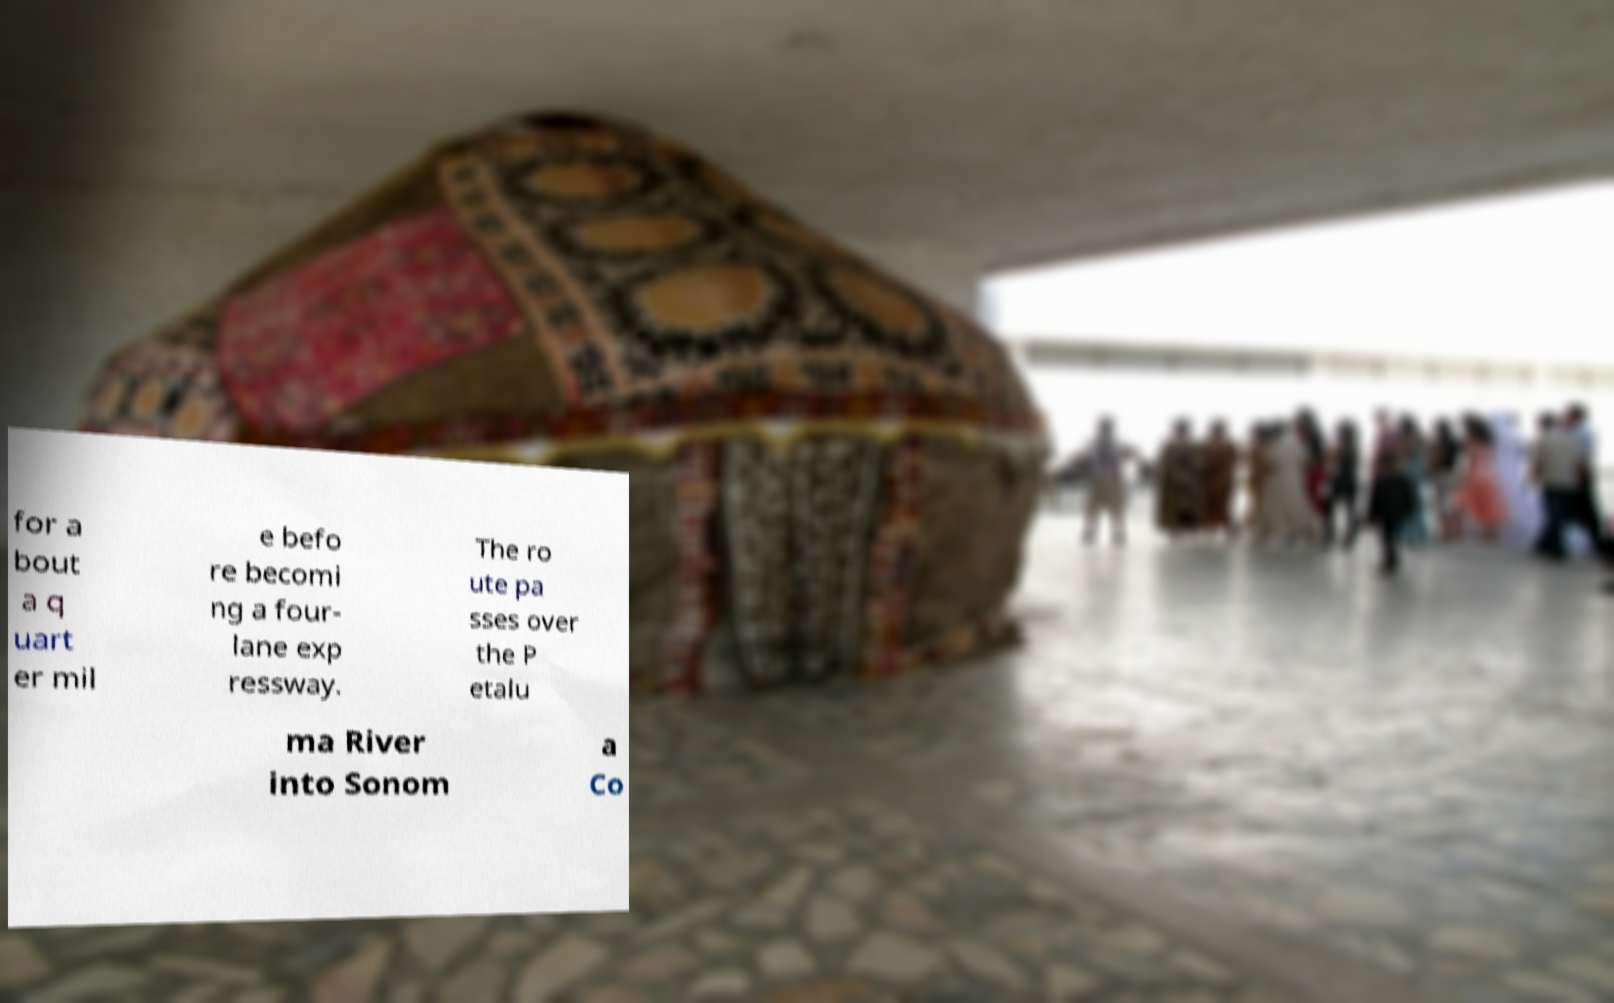For documentation purposes, I need the text within this image transcribed. Could you provide that? for a bout a q uart er mil e befo re becomi ng a four- lane exp ressway. The ro ute pa sses over the P etalu ma River into Sonom a Co 